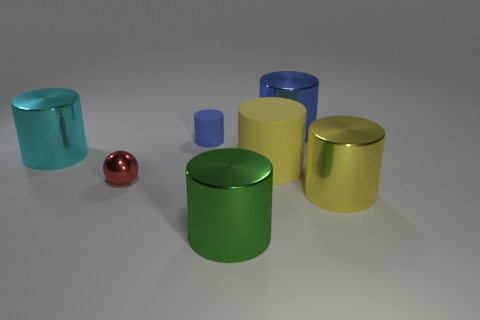Are there any small red things that have the same material as the small red ball?
Offer a very short reply. No. There is a cyan thing that is the same size as the blue metallic cylinder; what is its material?
Offer a very short reply. Metal. Are there fewer big blue metallic cylinders right of the large yellow metal object than big yellow things behind the red thing?
Ensure brevity in your answer.  Yes. What shape is the shiny thing that is behind the small shiny sphere and on the right side of the small blue object?
Your answer should be compact. Cylinder. How many small red shiny things have the same shape as the big green shiny thing?
Ensure brevity in your answer.  0. What is the size of the green object that is made of the same material as the small ball?
Offer a terse response. Large. Are there more cyan metallic things than blue cubes?
Provide a succinct answer. Yes. There is a big cylinder that is to the left of the small red metallic thing; what is its color?
Keep it short and to the point. Cyan. There is a shiny cylinder that is both in front of the small red ball and behind the large green thing; how big is it?
Provide a short and direct response. Large. How many cyan cylinders are the same size as the yellow metal cylinder?
Your answer should be compact. 1. 